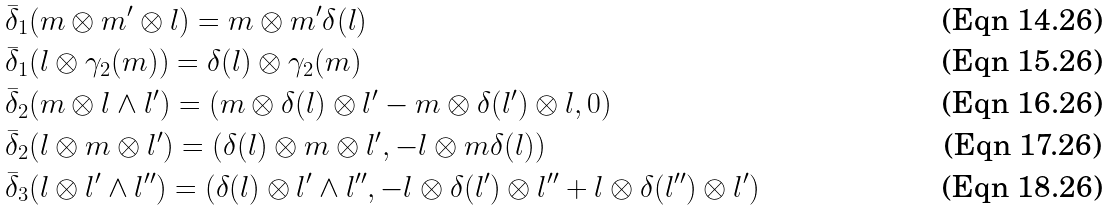<formula> <loc_0><loc_0><loc_500><loc_500>& \bar { \delta } _ { 1 } ( m \otimes m ^ { \prime } \otimes l ) = m \otimes m ^ { \prime } \delta ( l ) \\ & \bar { \delta } _ { 1 } ( l \otimes \gamma _ { 2 } ( m ) ) = \delta ( l ) \otimes \gamma _ { 2 } ( m ) \\ & \bar { \delta } _ { 2 } ( m \otimes l \wedge l ^ { \prime } ) = ( m \otimes \delta ( l ) \otimes l ^ { \prime } - m \otimes \delta ( l ^ { \prime } ) \otimes l , 0 ) \\ & \bar { \delta } _ { 2 } ( l \otimes m \otimes l ^ { \prime } ) = ( \delta ( l ) \otimes m \otimes l ^ { \prime } , - l \otimes m \delta ( l ) ) \\ & \bar { \delta } _ { 3 } ( l \otimes l ^ { \prime } \wedge l ^ { \prime \prime } ) = ( \delta ( l ) \otimes l ^ { \prime } \wedge l ^ { \prime \prime } , - l \otimes \delta ( l ^ { \prime } ) \otimes l ^ { \prime \prime } + l \otimes \delta ( l ^ { \prime \prime } ) \otimes l ^ { \prime } )</formula> 